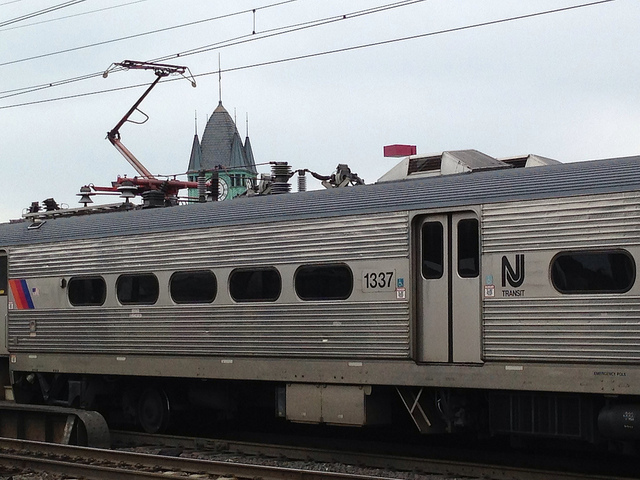<image>Where is the train at? I am not sure where the train is at. It can be seen at the station or on tracks. Where is the train at? I am not sure where the train is at. It can be at the station or on the tracks. 